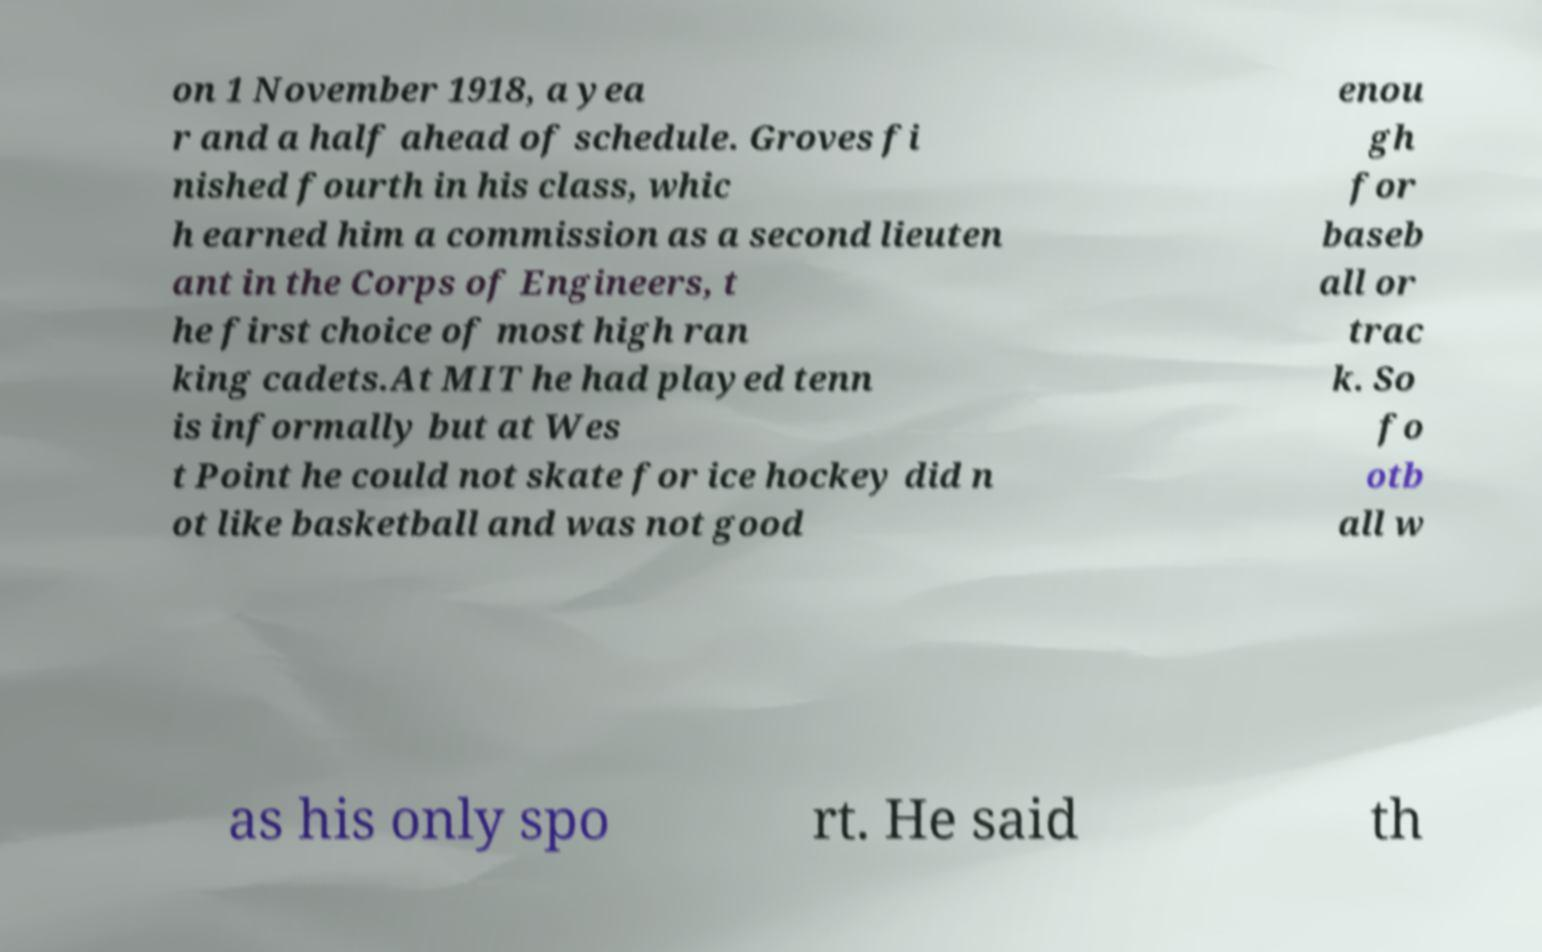What messages or text are displayed in this image? I need them in a readable, typed format. on 1 November 1918, a yea r and a half ahead of schedule. Groves fi nished fourth in his class, whic h earned him a commission as a second lieuten ant in the Corps of Engineers, t he first choice of most high ran king cadets.At MIT he had played tenn is informally but at Wes t Point he could not skate for ice hockey did n ot like basketball and was not good enou gh for baseb all or trac k. So fo otb all w as his only spo rt. He said th 